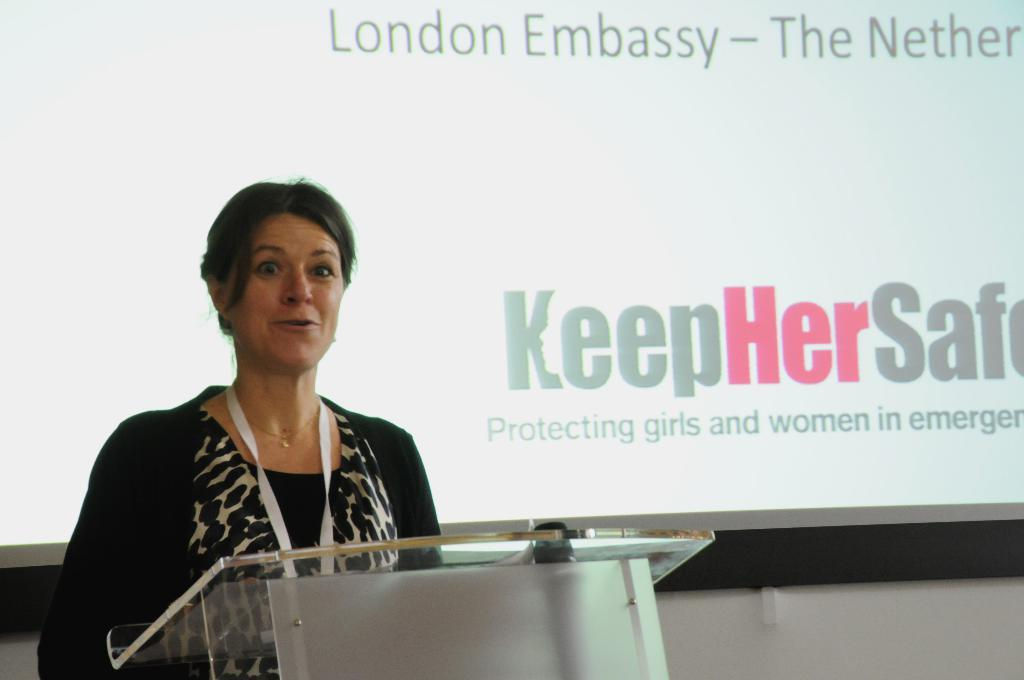Who is the main subject in the image? There is a lady in the image. What is the lady doing in the image? The lady is standing in front of a podium and talking. What can be seen in the background of the image? There is a wall and a board in the background of the image. What type of loaf is being sliced on the board in the image? There is no loaf present in the image, and no slicing is taking place. 